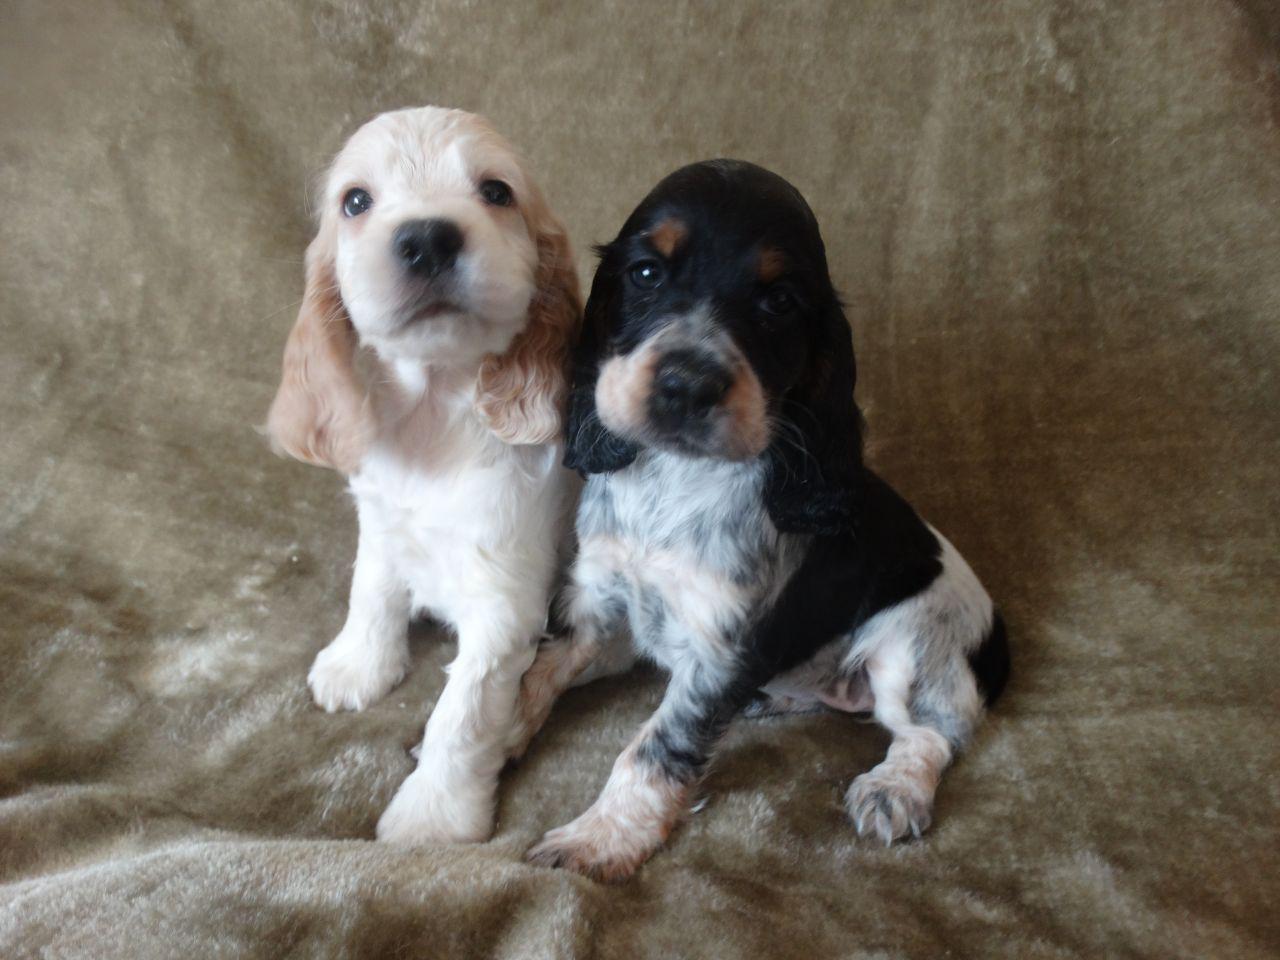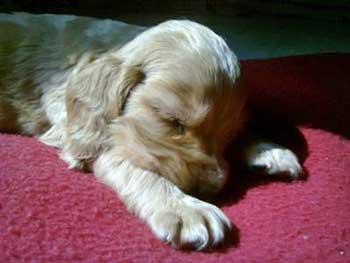The first image is the image on the left, the second image is the image on the right. Analyze the images presented: Is the assertion "A single puppy is lying on a carpet in one of the images." valid? Answer yes or no. Yes. The first image is the image on the left, the second image is the image on the right. Considering the images on both sides, is "The right image contains at least three times as many puppies as the left image." valid? Answer yes or no. No. 